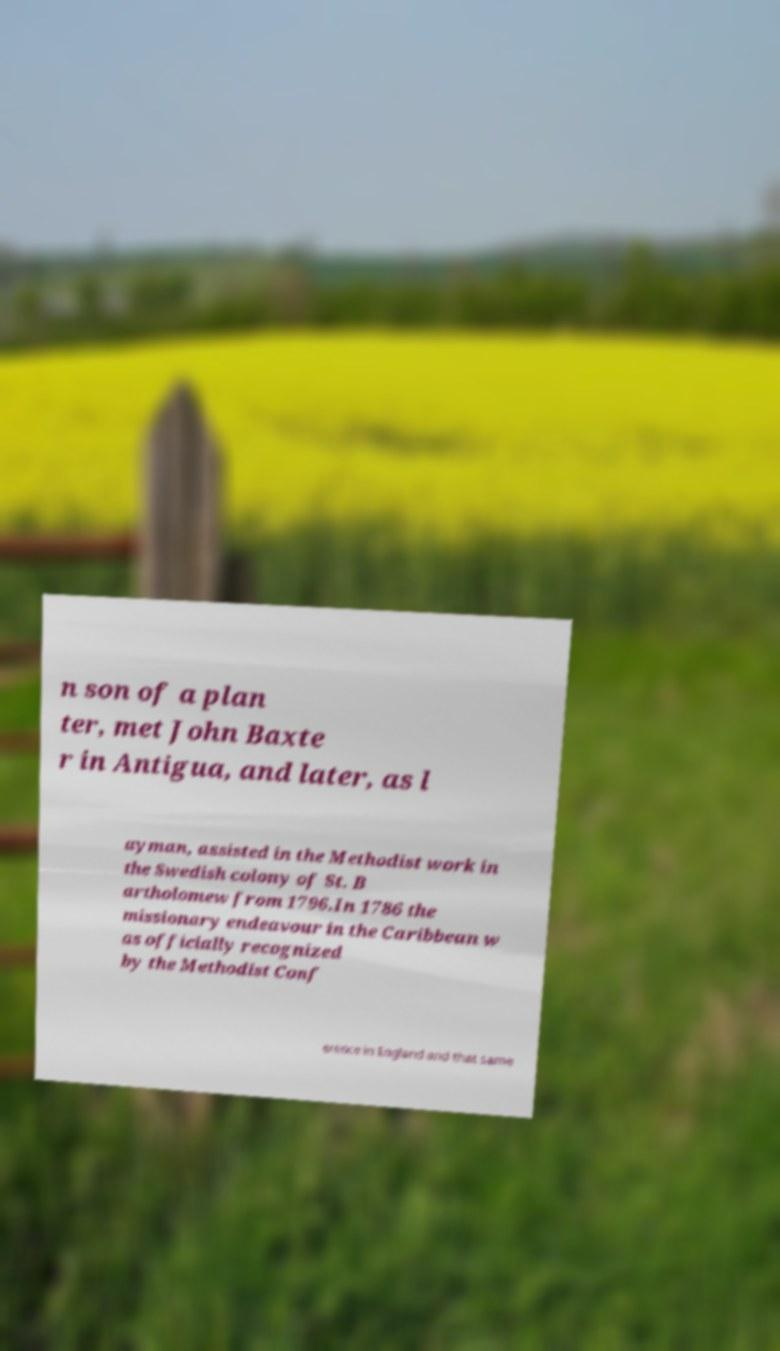Can you accurately transcribe the text from the provided image for me? n son of a plan ter, met John Baxte r in Antigua, and later, as l ayman, assisted in the Methodist work in the Swedish colony of St. B artholomew from 1796.In 1786 the missionary endeavour in the Caribbean w as officially recognized by the Methodist Conf erence in England and that same 